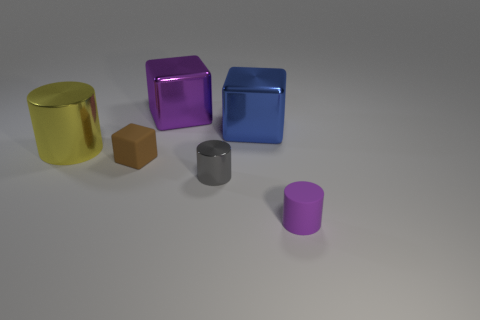Subtract all large metallic cubes. How many cubes are left? 1 Subtract all purple cylinders. How many cylinders are left? 2 Add 3 tiny purple rubber cylinders. How many objects exist? 9 Subtract all large yellow shiny cylinders. Subtract all large yellow cylinders. How many objects are left? 4 Add 6 tiny brown matte objects. How many tiny brown matte objects are left? 7 Add 3 metal cylinders. How many metal cylinders exist? 5 Subtract 0 cyan cylinders. How many objects are left? 6 Subtract all red cylinders. Subtract all green blocks. How many cylinders are left? 3 Subtract all purple cylinders. How many red cubes are left? 0 